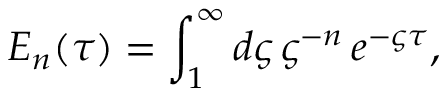Convert formula to latex. <formula><loc_0><loc_0><loc_500><loc_500>E _ { n } ( \tau ) = \int _ { 1 } ^ { \infty } d \varsigma \, \varsigma ^ { - n } \, e ^ { - \varsigma \tau } ,</formula> 